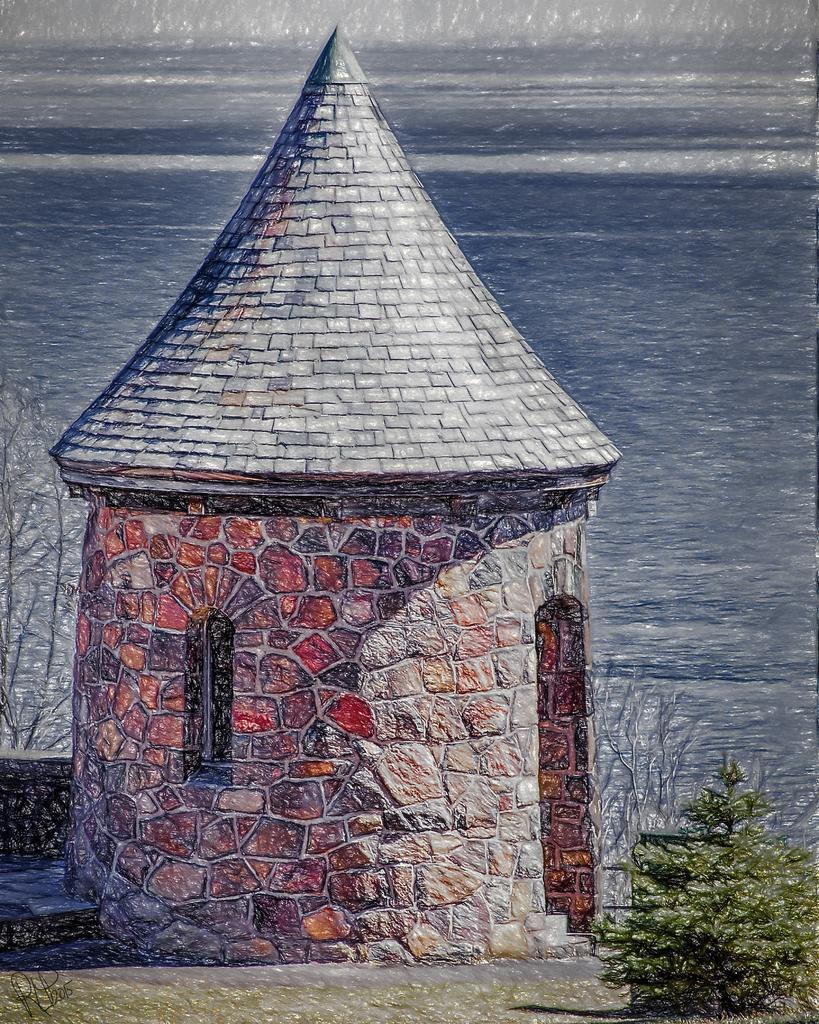Could you give a brief overview of what you see in this image? In this image we can see the drawing of a hit with a roof, stairs and a door. We can also see some plants and a large water body. 